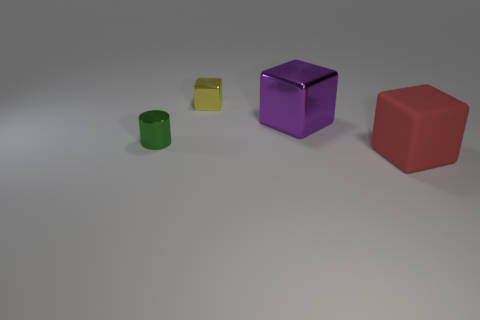Add 4 cubes. How many objects exist? 8 Subtract all cylinders. How many objects are left? 3 Subtract all yellow cubes. How many cubes are left? 2 Subtract 1 cylinders. How many cylinders are left? 0 Subtract all purple cylinders. Subtract all yellow blocks. How many cylinders are left? 1 Subtract all purple cylinders. How many red blocks are left? 1 Subtract all gray rubber spheres. Subtract all tiny green objects. How many objects are left? 3 Add 2 shiny things. How many shiny things are left? 5 Add 1 green spheres. How many green spheres exist? 1 Subtract all purple cubes. How many cubes are left? 2 